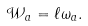<formula> <loc_0><loc_0><loc_500><loc_500>\mathcal { W } _ { a } = \ell \omega _ { a } .</formula> 